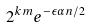Convert formula to latex. <formula><loc_0><loc_0><loc_500><loc_500>2 ^ { k m } e ^ { - \epsilon \alpha n / 2 }</formula> 